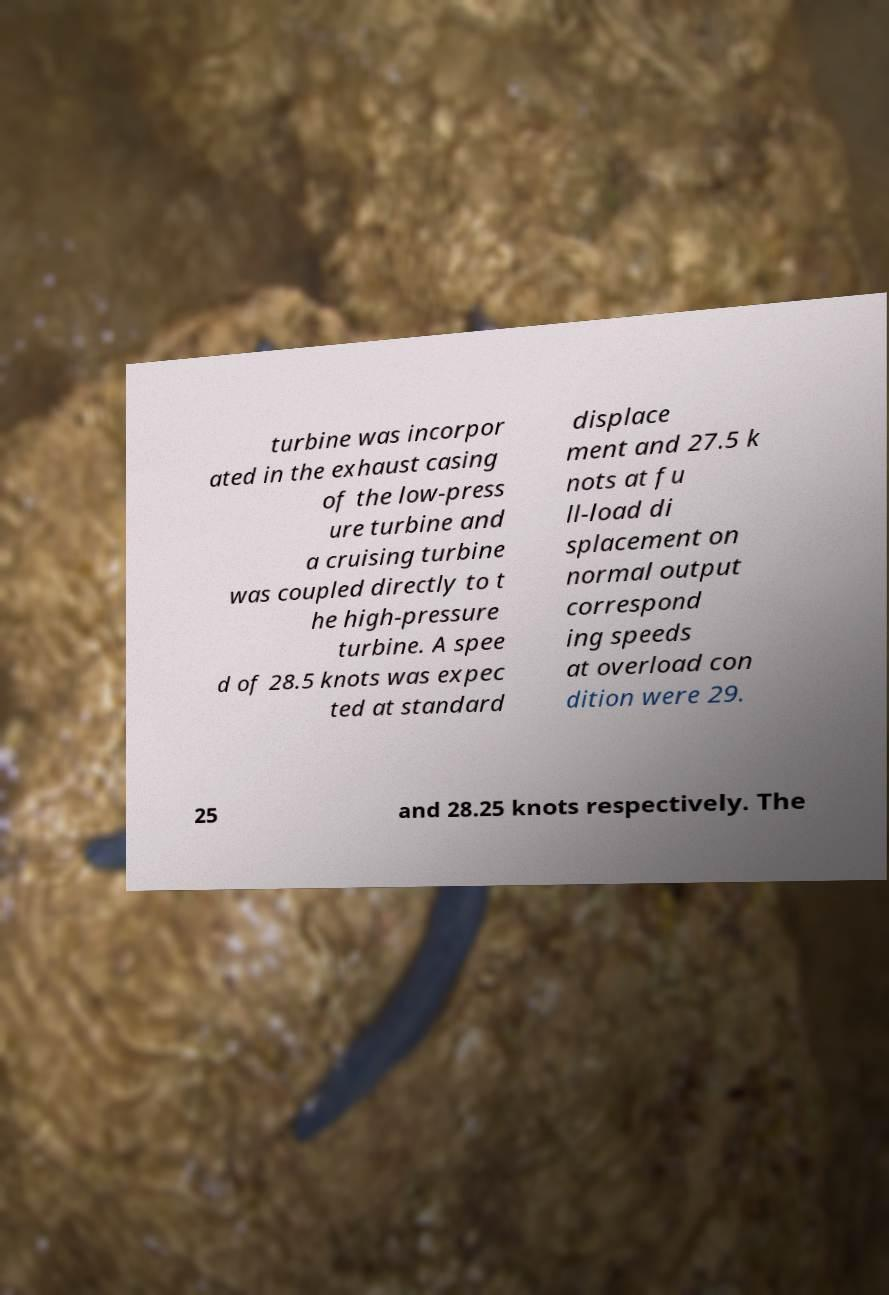I need the written content from this picture converted into text. Can you do that? turbine was incorpor ated in the exhaust casing of the low-press ure turbine and a cruising turbine was coupled directly to t he high-pressure turbine. A spee d of 28.5 knots was expec ted at standard displace ment and 27.5 k nots at fu ll-load di splacement on normal output correspond ing speeds at overload con dition were 29. 25 and 28.25 knots respectively. The 